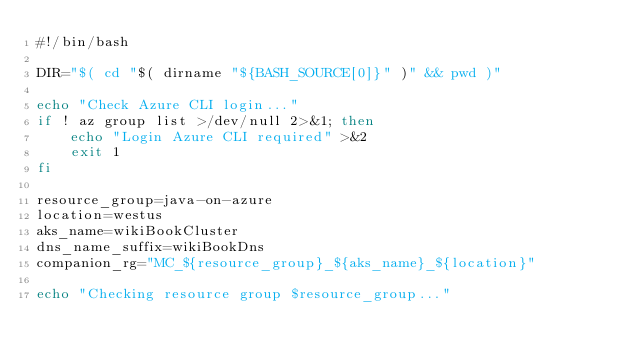Convert code to text. <code><loc_0><loc_0><loc_500><loc_500><_Bash_>#!/bin/bash

DIR="$( cd "$( dirname "${BASH_SOURCE[0]}" )" && pwd )"

echo "Check Azure CLI login..."
if ! az group list >/dev/null 2>&1; then
    echo "Login Azure CLI required" >&2
    exit 1
fi

resource_group=java-on-azure
location=westus
aks_name=wikiBookCluster
dns_name_suffix=wikiBookDns
companion_rg="MC_${resource_group}_${aks_name}_${location}"

echo "Checking resource group $resource_group..."</code> 